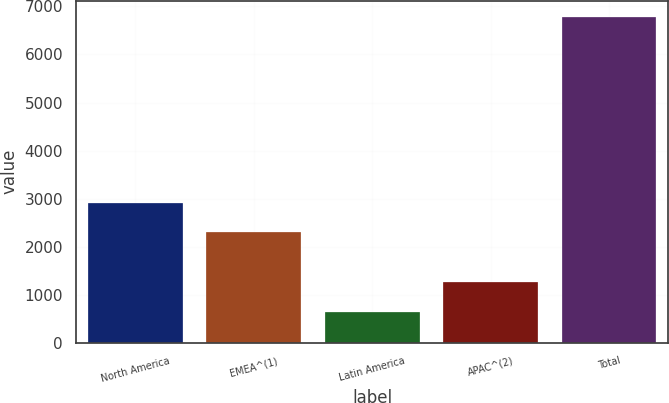Convert chart. <chart><loc_0><loc_0><loc_500><loc_500><bar_chart><fcel>North America<fcel>EMEA^(1)<fcel>Latin America<fcel>APAC^(2)<fcel>Total<nl><fcel>2916.22<fcel>2302.5<fcel>641.1<fcel>1254.82<fcel>6778.3<nl></chart> 